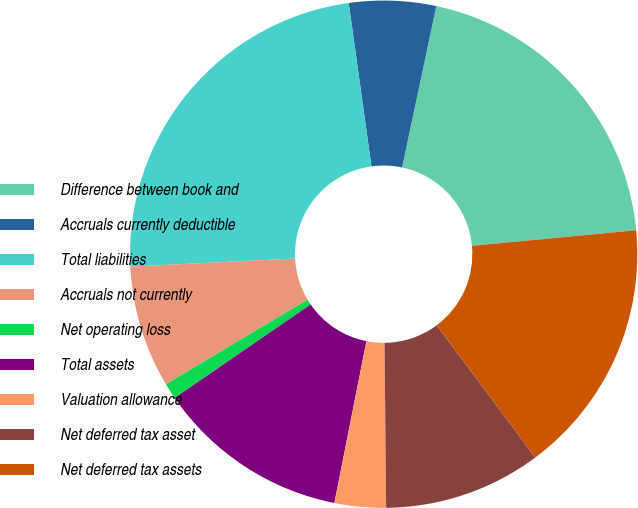<chart> <loc_0><loc_0><loc_500><loc_500><pie_chart><fcel>Difference between book and<fcel>Accruals currently deductible<fcel>Total liabilities<fcel>Accruals not currently<fcel>Net operating loss<fcel>Total assets<fcel>Valuation allowance<fcel>Net deferred tax asset<fcel>Net deferred tax assets<nl><fcel>20.17%<fcel>5.53%<fcel>23.58%<fcel>7.79%<fcel>1.02%<fcel>12.3%<fcel>3.27%<fcel>10.04%<fcel>16.31%<nl></chart> 